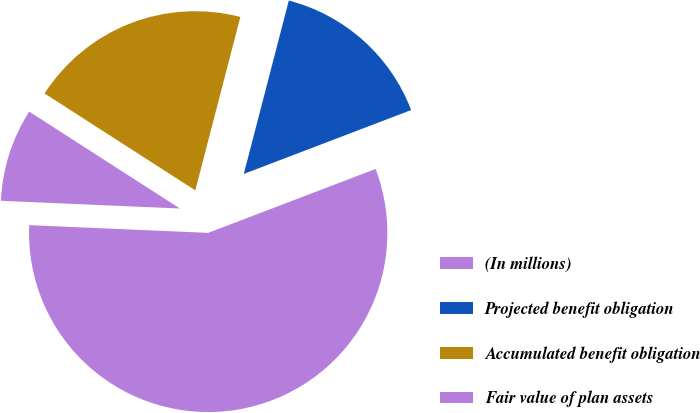Convert chart. <chart><loc_0><loc_0><loc_500><loc_500><pie_chart><fcel>(In millions)<fcel>Projected benefit obligation<fcel>Accumulated benefit obligation<fcel>Fair value of plan assets<nl><fcel>56.49%<fcel>15.15%<fcel>19.95%<fcel>8.41%<nl></chart> 